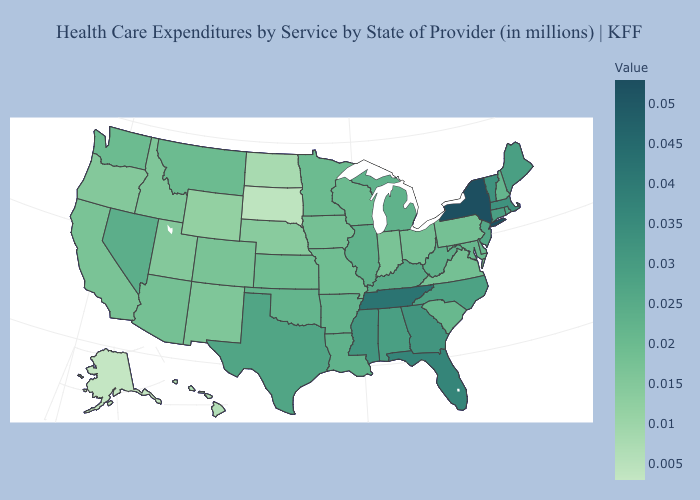Among the states that border Nevada , which have the lowest value?
Short answer required. Oregon, Utah. Among the states that border Montana , does Wyoming have the highest value?
Keep it brief. No. Does Idaho have a lower value than Hawaii?
Be succinct. No. Does Maryland have the lowest value in the USA?
Be succinct. No. Does Alaska have the lowest value in the USA?
Keep it brief. Yes. Does Massachusetts have the highest value in the Northeast?
Short answer required. No. Does Idaho have a lower value than Hawaii?
Quick response, please. No. Which states have the lowest value in the Northeast?
Write a very short answer. Pennsylvania. 